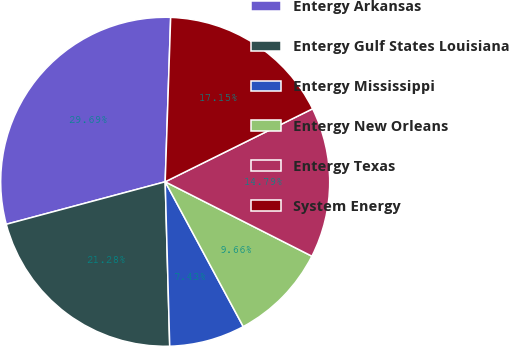Convert chart to OTSL. <chart><loc_0><loc_0><loc_500><loc_500><pie_chart><fcel>Entergy Arkansas<fcel>Entergy Gulf States Louisiana<fcel>Entergy Mississippi<fcel>Entergy New Orleans<fcel>Entergy Texas<fcel>System Energy<nl><fcel>29.69%<fcel>21.28%<fcel>7.43%<fcel>9.66%<fcel>14.79%<fcel>17.15%<nl></chart> 